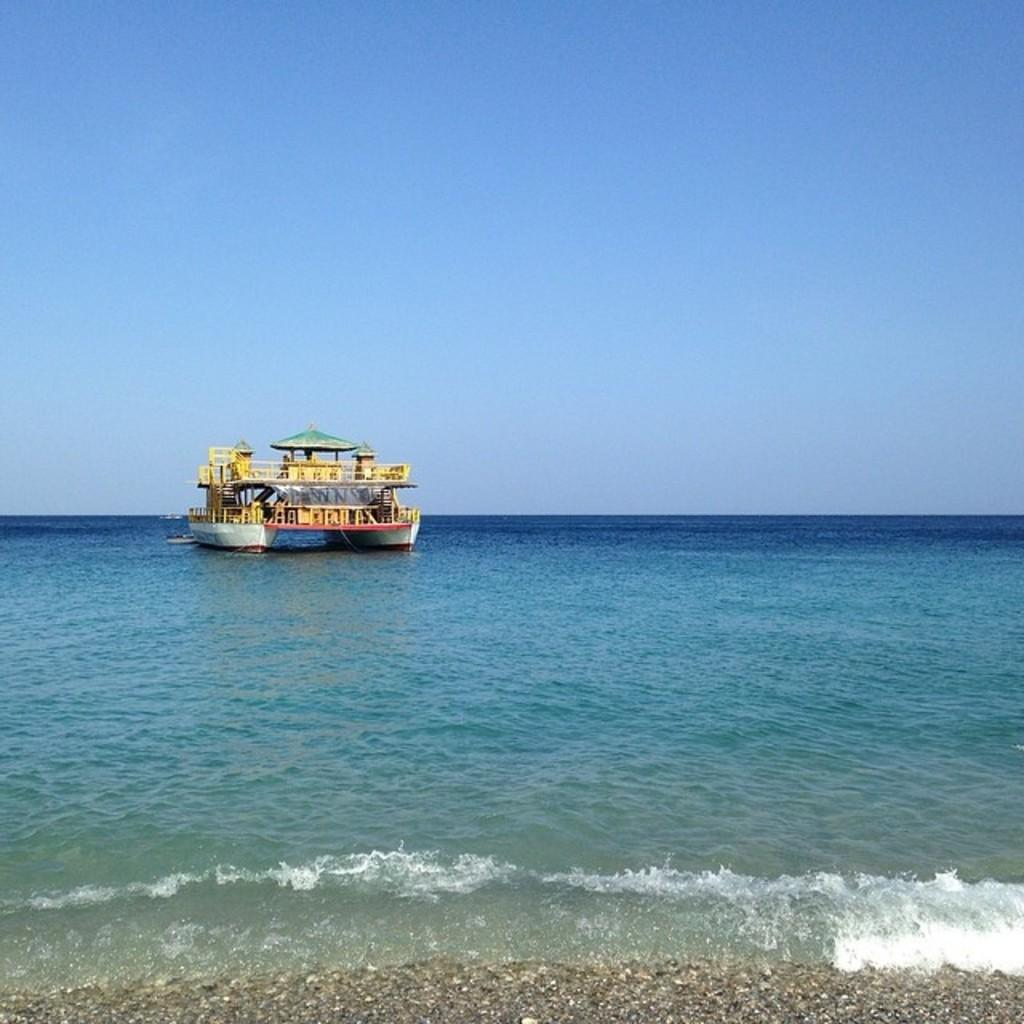What is the main subject of the image? The main subject of the image is a boat. What is the boat doing in the image? The boat is sailing on water. What is the condition of the water in the image? The water has tides. What is visible at the bottom of the image? There is land visible at the bottom of the image. What is visible at the top of the image? The sky is visible at the top of the image. What type of market can be seen in the image? There is no market present in the image; it features a boat sailing on water with tides. What emotion is the boat displaying in the image? Boats do not have emotions, so it is not possible to determine the boat's emotional state from the image. 